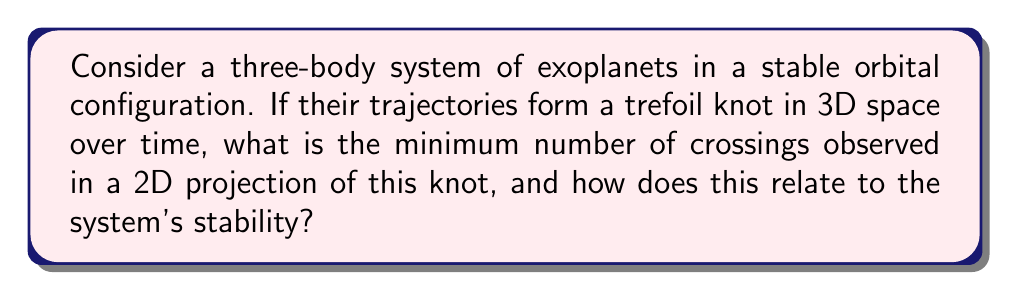Solve this math problem. To analyze this problem, we'll follow these steps:

1) First, recall that the trefoil knot is the simplest non-trivial knot in knot theory. It's classified as a $(2,3)$-torus knot.

2) The minimum number of crossings for a trefoil knot in any 2D projection is always 3. This is a fundamental property of the trefoil knot.

3) In the context of a three-body system:
   - Each crossing in the 2D projection represents a close approach between two bodies in the 3D space.
   - The stability of the system is related to these close approaches.

4) The trefoil knot's structure implies that each body in the system will have at least one close approach with each of the other two bodies during one complete cycle.

5) The stability of the system can be related to the knot's invariants:
   - The crossing number (3) indicates the minimum number of close approaches.
   - The unknotting number (1) suggests that a single change in the orbit could potentially destabilize the system.

6) In celestial mechanics, the stability of a three-body system is often analyzed using the Kolmogorov-Arnold-Moser (KAM) theory. The trefoil knot configuration could represent a quasi-periodic orbit in phase space, which KAM theory suggests can be stable under certain conditions.

7) The Jones polynomial for a trefoil knot is:

   $$V(t) = t + t^3 - t^4$$

   This polynomial could potentially be related to the system's energy levels or angular momentum distribution.

8) The fundamental group of the trefoil knot complement is:

   $$\pi_1(S^3 \setminus K) = \langle a,b | a^2 = b^3 \rangle$$

   This group structure might provide insights into the symmetries and constraints of the orbital configuration.
Answer: 3 crossings; stability related to close approaches and knot invariants 